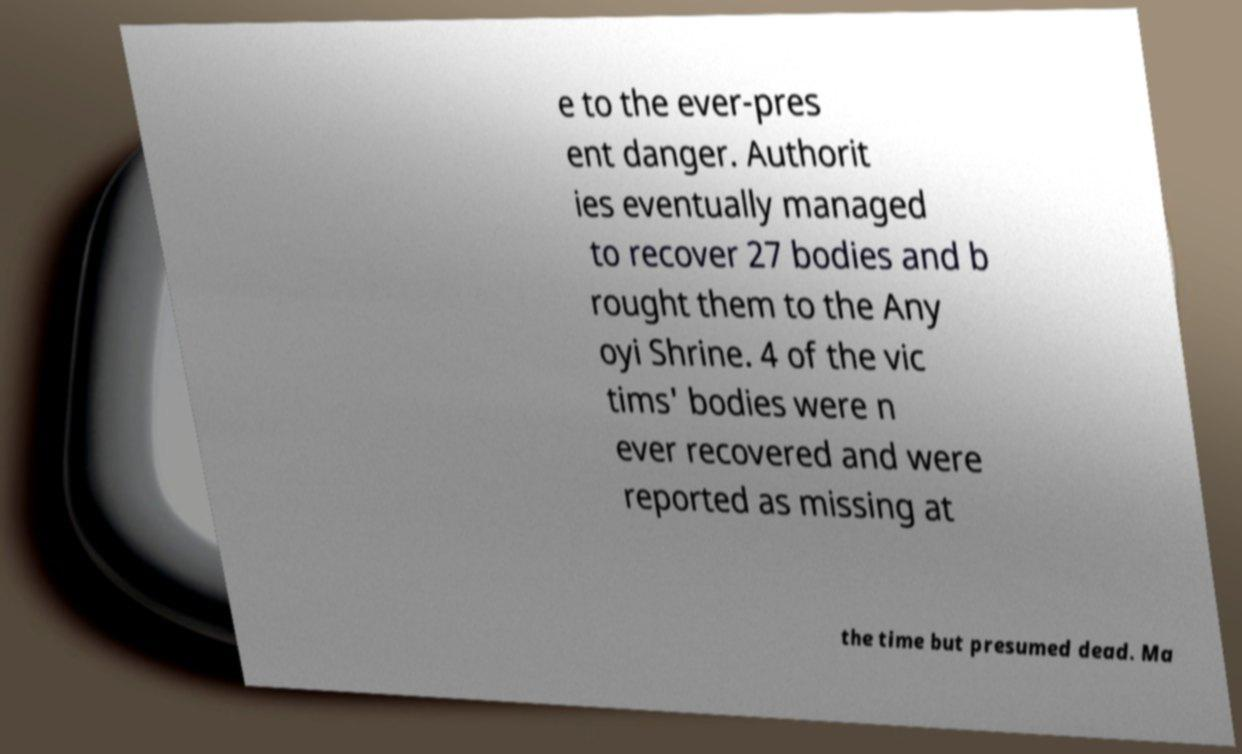Can you read and provide the text displayed in the image?This photo seems to have some interesting text. Can you extract and type it out for me? e to the ever-pres ent danger. Authorit ies eventually managed to recover 27 bodies and b rought them to the Any oyi Shrine. 4 of the vic tims' bodies were n ever recovered and were reported as missing at the time but presumed dead. Ma 